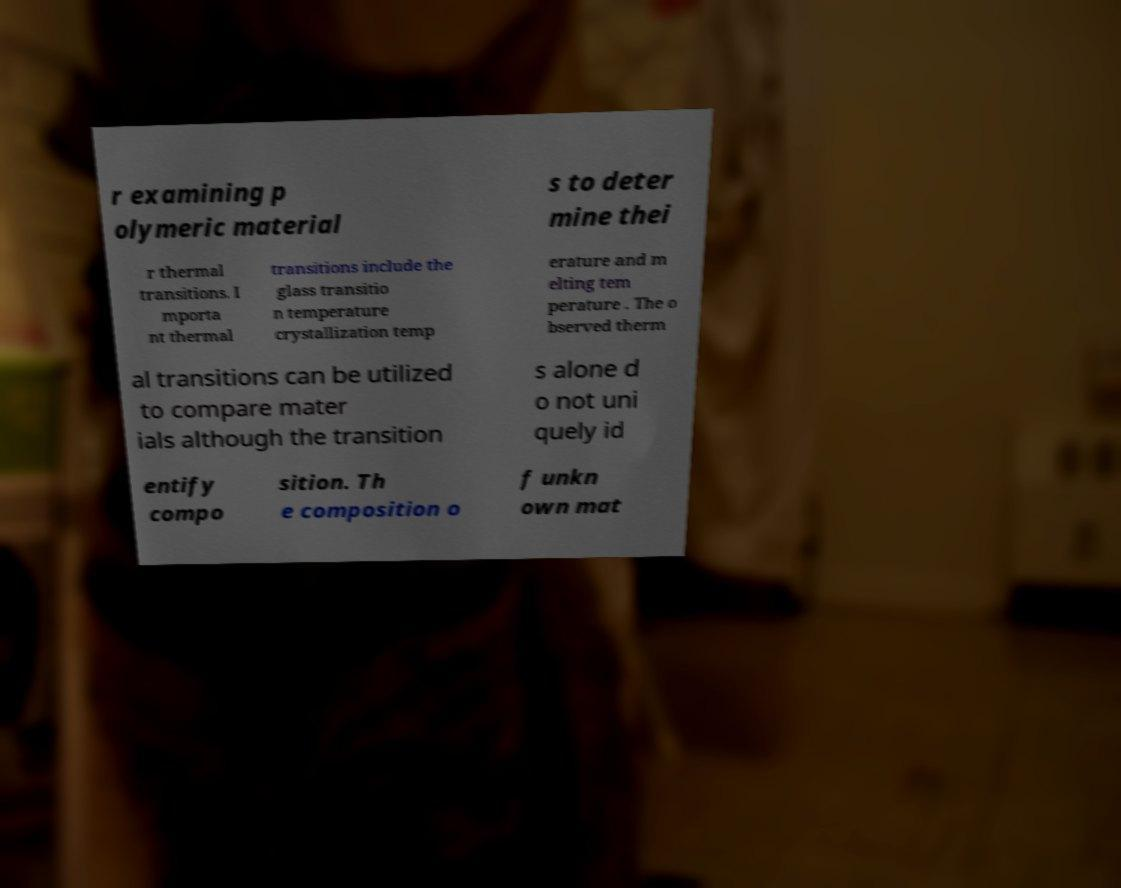For documentation purposes, I need the text within this image transcribed. Could you provide that? r examining p olymeric material s to deter mine thei r thermal transitions. I mporta nt thermal transitions include the glass transitio n temperature crystallization temp erature and m elting tem perature . The o bserved therm al transitions can be utilized to compare mater ials although the transition s alone d o not uni quely id entify compo sition. Th e composition o f unkn own mat 